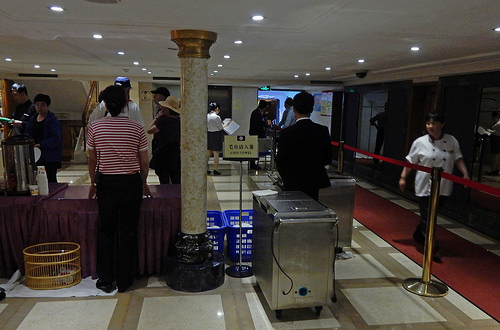<image>
Is there a basket on the floor? Yes. Looking at the image, I can see the basket is positioned on top of the floor, with the floor providing support. 